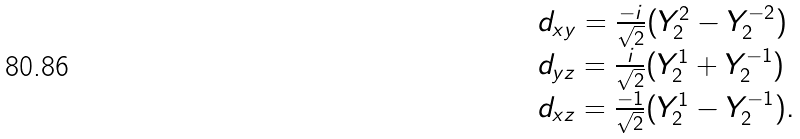Convert formula to latex. <formula><loc_0><loc_0><loc_500><loc_500>\begin{array} { l } d _ { x y } = \frac { - i } { \sqrt { 2 } } ( Y _ { 2 } ^ { 2 } - Y _ { 2 } ^ { - 2 } ) \\ d _ { y z } = \frac { i } { \sqrt { 2 } } ( Y _ { 2 } ^ { 1 } + Y _ { 2 } ^ { - 1 } ) \\ d _ { x z } = \frac { - 1 } { \sqrt { 2 } } ( Y _ { 2 } ^ { 1 } - Y _ { 2 } ^ { - 1 } ) . \end{array}</formula> 